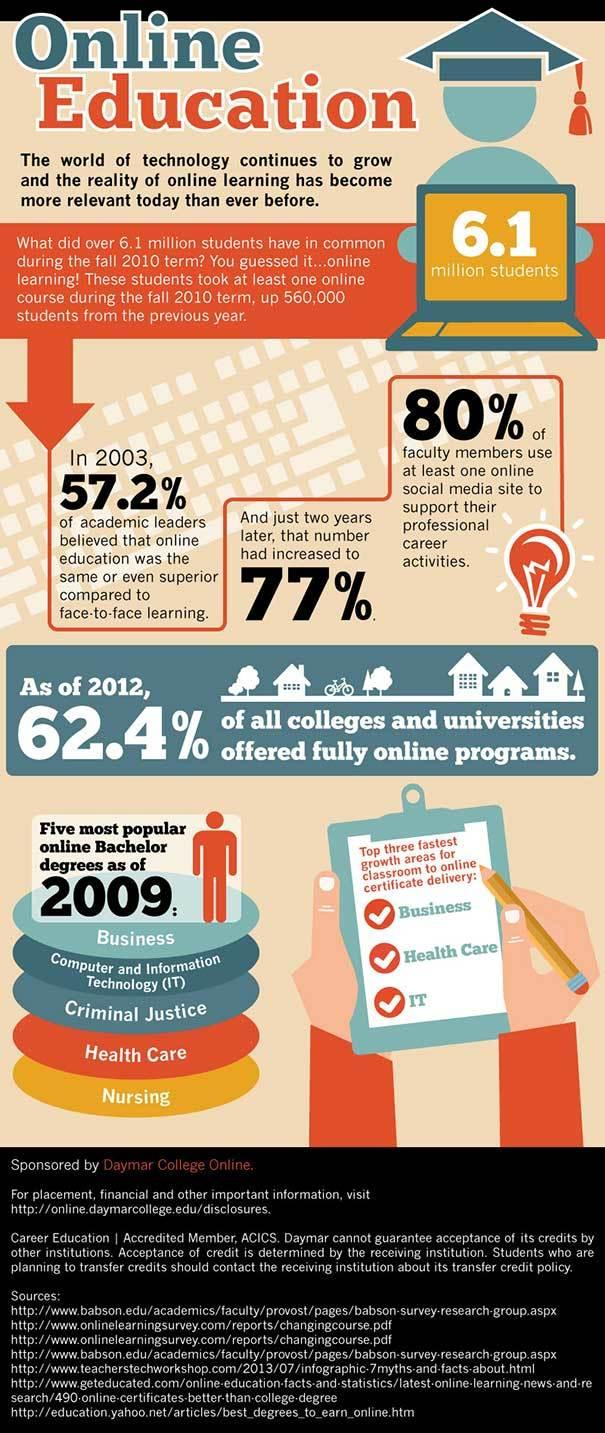Give some essential details in this illustration. In 2009, besides IT and Health Care, other popular online Bachelor's degree programs included Business, Criminal Justice, and Nursing. In 2005, a majority of academic leaders found online education to be either equal to or superior to traditional face-to-face learning, as compared to 2003, with 19.8% of them believing that online education was superior. In 2009, approximately 60,440,000 students took online courses. The color of the computer screen is yellow. The fastest growing areas for classroom to online certificate delivery are Business, Health Care, and IT. 